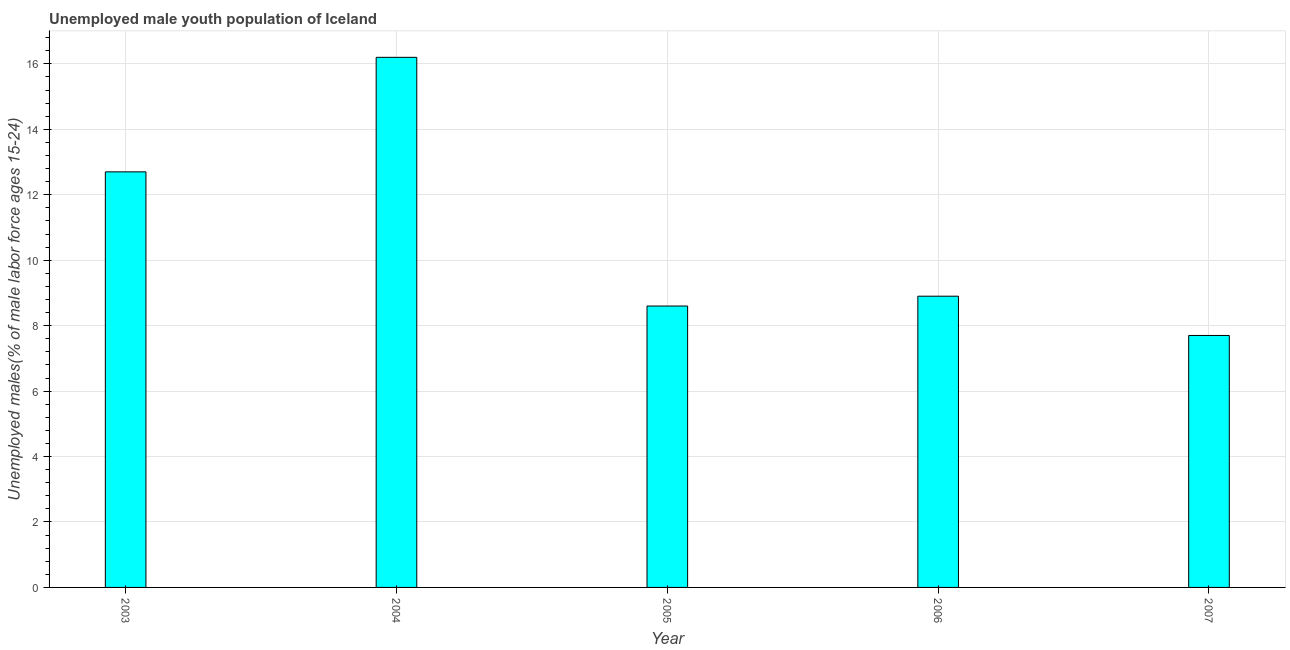What is the title of the graph?
Your response must be concise. Unemployed male youth population of Iceland. What is the label or title of the Y-axis?
Provide a short and direct response. Unemployed males(% of male labor force ages 15-24). What is the unemployed male youth in 2004?
Your answer should be compact. 16.2. Across all years, what is the maximum unemployed male youth?
Provide a succinct answer. 16.2. Across all years, what is the minimum unemployed male youth?
Provide a succinct answer. 7.7. In which year was the unemployed male youth maximum?
Make the answer very short. 2004. What is the sum of the unemployed male youth?
Your response must be concise. 54.1. What is the average unemployed male youth per year?
Provide a short and direct response. 10.82. What is the median unemployed male youth?
Provide a short and direct response. 8.9. In how many years, is the unemployed male youth greater than 11.2 %?
Your response must be concise. 2. What is the ratio of the unemployed male youth in 2005 to that in 2007?
Offer a terse response. 1.12. Is the unemployed male youth in 2004 less than that in 2005?
Provide a succinct answer. No. Is the difference between the unemployed male youth in 2004 and 2006 greater than the difference between any two years?
Keep it short and to the point. No. What is the difference between the highest and the lowest unemployed male youth?
Ensure brevity in your answer.  8.5. How many bars are there?
Your answer should be very brief. 5. Are all the bars in the graph horizontal?
Your answer should be very brief. No. How many years are there in the graph?
Offer a terse response. 5. What is the difference between two consecutive major ticks on the Y-axis?
Make the answer very short. 2. What is the Unemployed males(% of male labor force ages 15-24) in 2003?
Offer a very short reply. 12.7. What is the Unemployed males(% of male labor force ages 15-24) in 2004?
Provide a succinct answer. 16.2. What is the Unemployed males(% of male labor force ages 15-24) in 2005?
Provide a short and direct response. 8.6. What is the Unemployed males(% of male labor force ages 15-24) of 2006?
Give a very brief answer. 8.9. What is the Unemployed males(% of male labor force ages 15-24) of 2007?
Make the answer very short. 7.7. What is the difference between the Unemployed males(% of male labor force ages 15-24) in 2003 and 2004?
Provide a short and direct response. -3.5. What is the difference between the Unemployed males(% of male labor force ages 15-24) in 2003 and 2005?
Provide a succinct answer. 4.1. What is the difference between the Unemployed males(% of male labor force ages 15-24) in 2003 and 2006?
Offer a very short reply. 3.8. What is the difference between the Unemployed males(% of male labor force ages 15-24) in 2004 and 2007?
Give a very brief answer. 8.5. What is the ratio of the Unemployed males(% of male labor force ages 15-24) in 2003 to that in 2004?
Your response must be concise. 0.78. What is the ratio of the Unemployed males(% of male labor force ages 15-24) in 2003 to that in 2005?
Your response must be concise. 1.48. What is the ratio of the Unemployed males(% of male labor force ages 15-24) in 2003 to that in 2006?
Give a very brief answer. 1.43. What is the ratio of the Unemployed males(% of male labor force ages 15-24) in 2003 to that in 2007?
Give a very brief answer. 1.65. What is the ratio of the Unemployed males(% of male labor force ages 15-24) in 2004 to that in 2005?
Offer a terse response. 1.88. What is the ratio of the Unemployed males(% of male labor force ages 15-24) in 2004 to that in 2006?
Provide a succinct answer. 1.82. What is the ratio of the Unemployed males(% of male labor force ages 15-24) in 2004 to that in 2007?
Make the answer very short. 2.1. What is the ratio of the Unemployed males(% of male labor force ages 15-24) in 2005 to that in 2006?
Ensure brevity in your answer.  0.97. What is the ratio of the Unemployed males(% of male labor force ages 15-24) in 2005 to that in 2007?
Offer a terse response. 1.12. What is the ratio of the Unemployed males(% of male labor force ages 15-24) in 2006 to that in 2007?
Your answer should be compact. 1.16. 